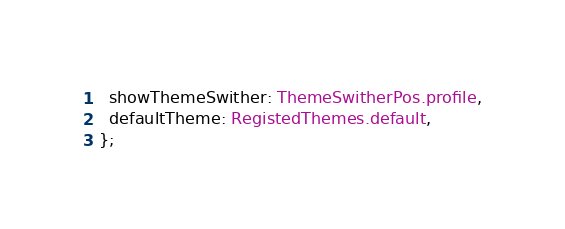<code> <loc_0><loc_0><loc_500><loc_500><_TypeScript_>  showThemeSwither: ThemeSwitherPos.profile,
  defaultTheme: RegistedThemes.default,
};
</code> 